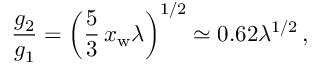<formula> <loc_0><loc_0><loc_500><loc_500>\frac { g _ { 2 } } { g _ { 1 } } = \left ( \frac { 5 } { 3 } \, x _ { w } \lambda \right ) ^ { 1 / 2 } \simeq 0 . 6 2 \lambda ^ { 1 / 2 } \, ,</formula> 